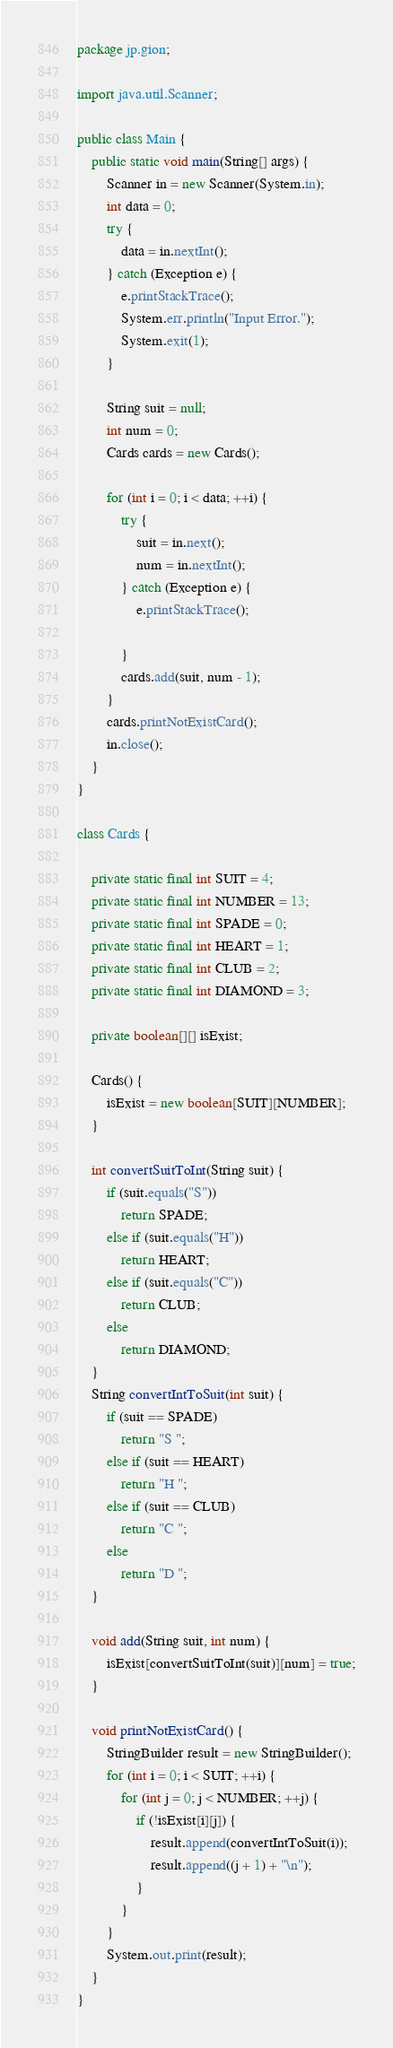Convert code to text. <code><loc_0><loc_0><loc_500><loc_500><_Java_>package jp.gion;

import java.util.Scanner;

public class Main {
	public static void main(String[] args) {
		Scanner in = new Scanner(System.in);
		int data = 0;
		try {
			data = in.nextInt();
		} catch (Exception e) {
			e.printStackTrace();
			System.err.println("Input Error.");
			System.exit(1);
		}
		
		String suit = null;
		int num = 0;
		Cards cards = new Cards();
		
		for (int i = 0; i < data; ++i) {
			try {
				suit = in.next();
				num = in.nextInt();
			} catch (Exception e) {
				e.printStackTrace();
				
			}
			cards.add(suit, num - 1);
		}
		cards.printNotExistCard();
		in.close();
	}
}

class Cards {
	
    private static final int SUIT = 4;
    private static final int NUMBER = 13;
    private static final int SPADE = 0;
    private static final int HEART = 1;
    private static final int CLUB = 2;
    private static final int DIAMOND = 3;
	
	private boolean[][] isExist;
	
	Cards() {
		isExist = new boolean[SUIT][NUMBER];
	}
	
	int convertSuitToInt(String suit) {
		if (suit.equals("S"))
			return SPADE;
		else if (suit.equals("H"))
			return HEART;
		else if (suit.equals("C"))
			return CLUB;
		else
			return DIAMOND;
	}
	String convertIntToSuit(int suit) {
		if (suit == SPADE)
			return "S ";
		else if (suit == HEART)
			return "H ";
		else if (suit == CLUB)
			return "C ";
		else
			return "D ";
	}
	
	void add(String suit, int num) {
		isExist[convertSuitToInt(suit)][num] = true;
	}
	
	void printNotExistCard() {
		StringBuilder result = new StringBuilder();
		for (int i = 0; i < SUIT; ++i) {
			for (int j = 0; j < NUMBER; ++j) {
				if (!isExist[i][j]) {
					result.append(convertIntToSuit(i));
					result.append((j + 1) + "\n");
				}
			}
		}
		System.out.print(result);
	}
}</code> 